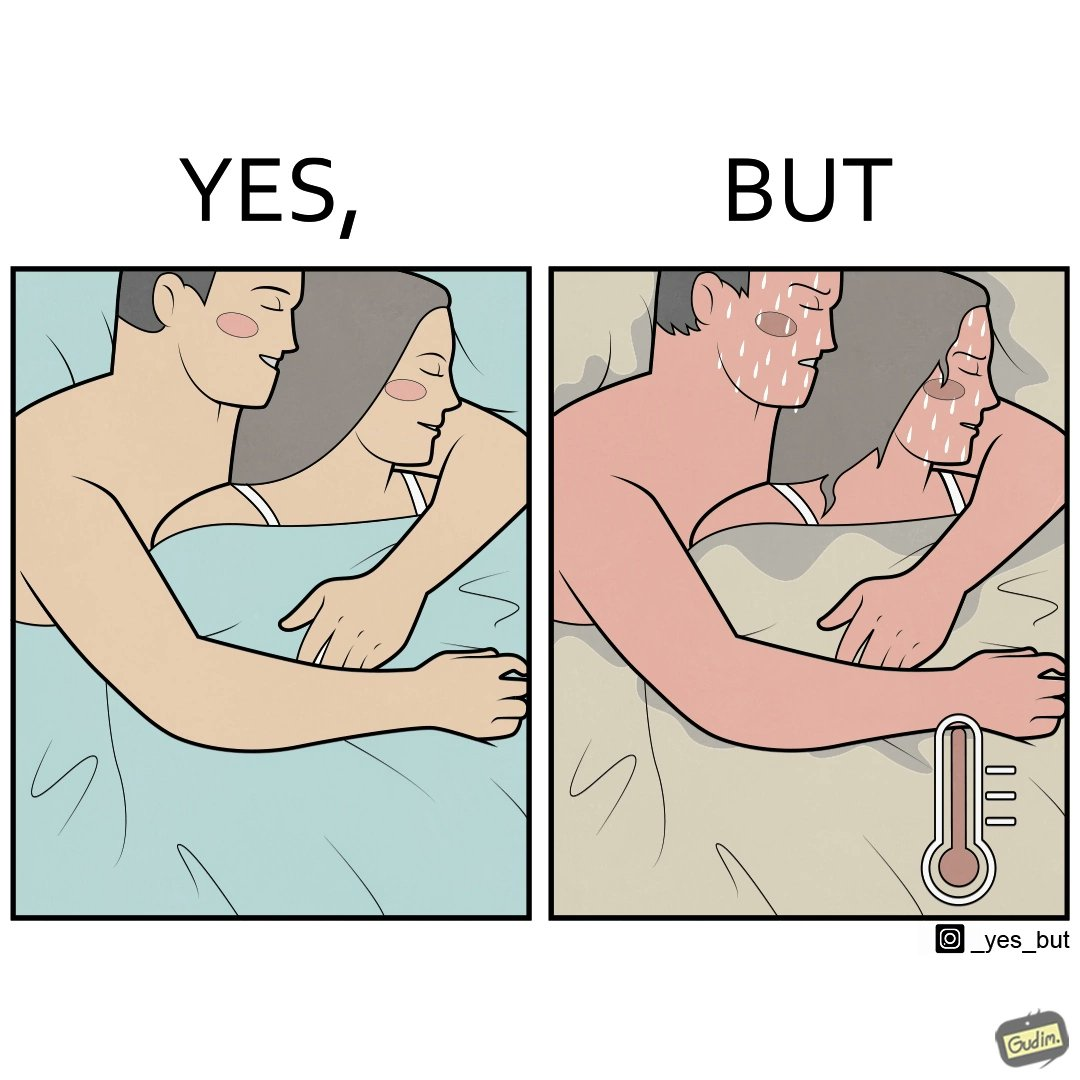Provide a description of this image. The image is ironic, because after some time cuddling within a blanket raises the temperature which leads to inconvenience 